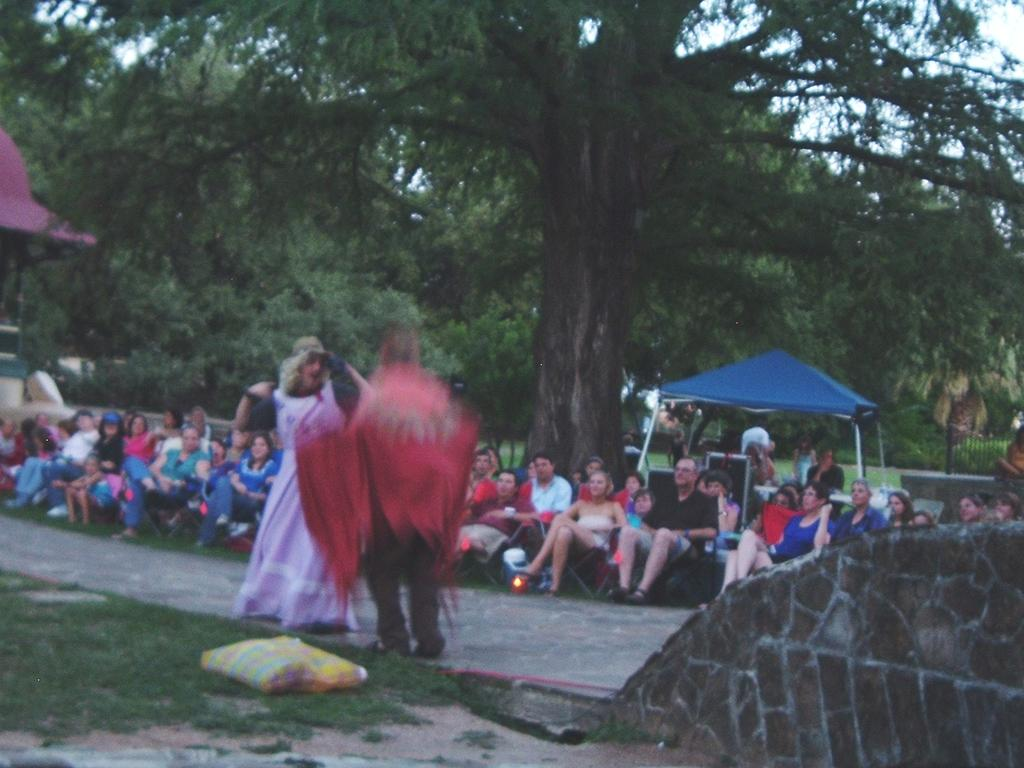What are the people in the image doing? The people in the image are sitting on chairs. Are there any other people in the image besides those sitting on chairs? Yes, there are people in front of the chairs. What can be seen in the background of the image? Trees, a blue tent, and fencing can be seen in the background. What type of star is visible on the throne in the image? There is no throne or star present in the image. 